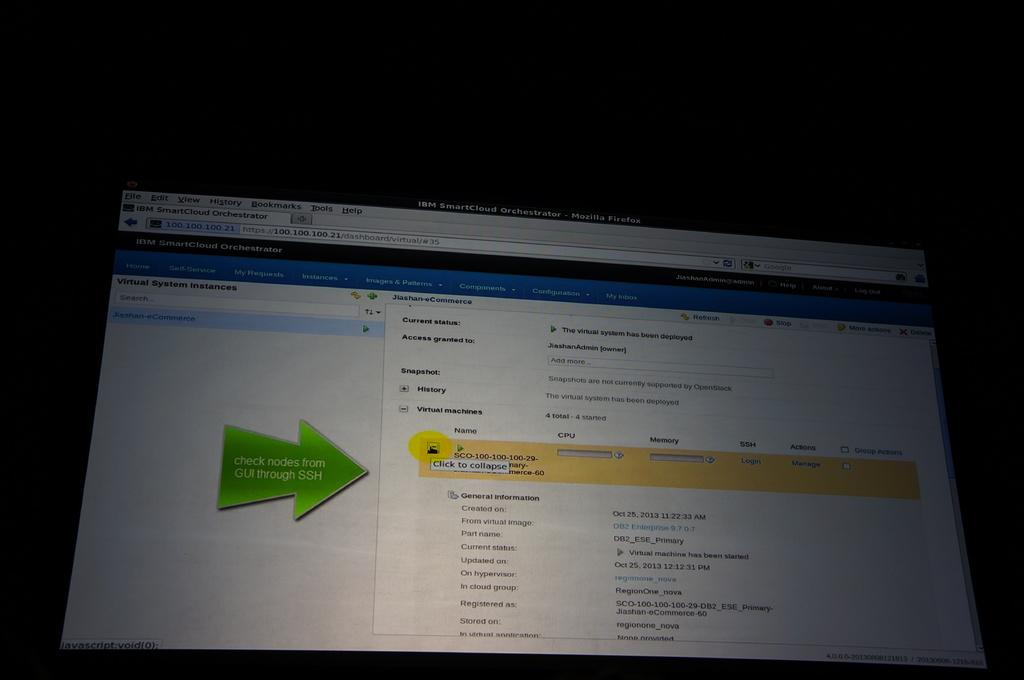<image>
Offer a succinct explanation of the picture presented. A computer screen is open to a site that says Check nodes from GUI through SSH 